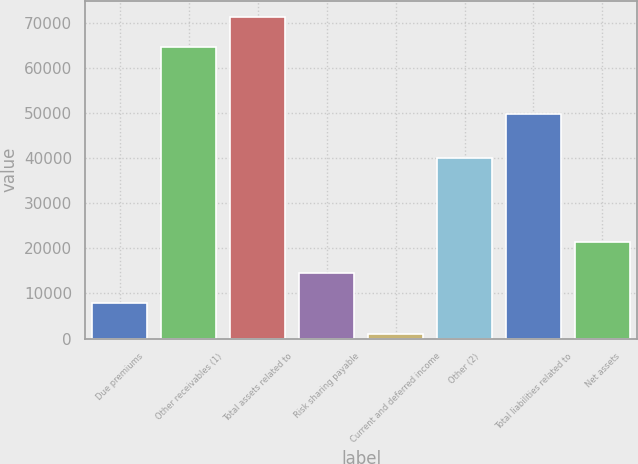<chart> <loc_0><loc_0><loc_500><loc_500><bar_chart><fcel>Due premiums<fcel>Other receivables (1)<fcel>Total assets related to<fcel>Risk sharing payable<fcel>Current and deferred income<fcel>Other (2)<fcel>Total liabilities related to<fcel>Net assets<nl><fcel>7821.3<fcel>64575<fcel>71319.3<fcel>14565.6<fcel>1077<fcel>40046<fcel>49854<fcel>21309.9<nl></chart> 